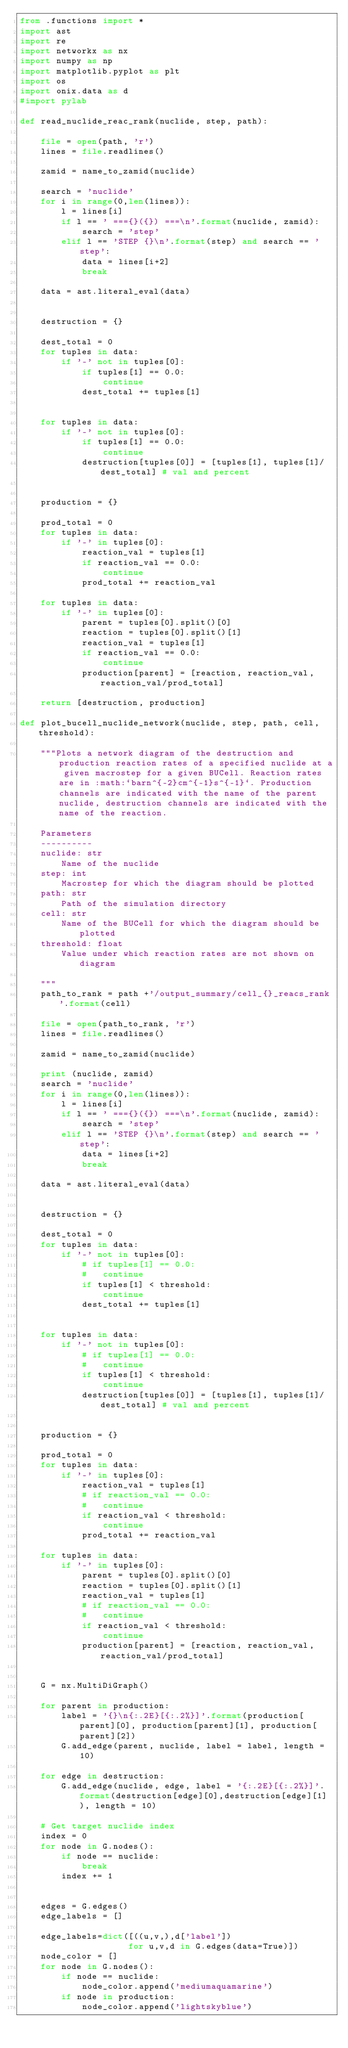Convert code to text. <code><loc_0><loc_0><loc_500><loc_500><_Python_>from .functions import *
import ast
import re
import networkx as nx
import numpy as np
import matplotlib.pyplot as plt
import os
import onix.data as d
#import pylab

def read_nuclide_reac_rank(nuclide, step, path):

    file = open(path, 'r')
    lines = file.readlines()

    zamid = name_to_zamid(nuclide)

    search = 'nuclide'
    for i in range(0,len(lines)):
        l = lines[i]
        if l == ' ==={}({}) ===\n'.format(nuclide, zamid):
            search = 'step'
        elif l == 'STEP {}\n'.format(step) and search == 'step':
            data = lines[i+2]
            break

    data = ast.literal_eval(data)


    destruction = {}

    dest_total = 0
    for tuples in data:
        if '-' not in tuples[0]:
            if tuples[1] == 0.0:
                continue
            dest_total += tuples[1]


    for tuples in data:
        if '-' not in tuples[0]:
            if tuples[1] == 0.0:
                continue
            destruction[tuples[0]] = [tuples[1], tuples[1]/dest_total] # val and percent


    production = {}

    prod_total = 0
    for tuples in data:
        if '-' in tuples[0]:
            reaction_val = tuples[1]
            if reaction_val == 0.0:
                continue    
            prod_total += reaction_val

    for tuples in data:
        if '-' in tuples[0]:
            parent = tuples[0].split()[0]
            reaction = tuples[0].split()[1]
            reaction_val = tuples[1]
            if reaction_val == 0.0:
                continue    
            production[parent] = [reaction, reaction_val, reaction_val/prod_total]

    return [destruction, production]

def plot_bucell_nuclide_network(nuclide, step, path, cell, threshold):
    
    """Plots a network diagram of the destruction and production reaction rates of a specified nuclide at a given macrostep for a given BUCell. Reaction rates are in :math:`barn^{-2}cm^{-1}s^{-1}`. Production channels are indicated with the name of the parent nuclide, destruction channels are indicated with the name of the reaction.

    Parameters
    ----------
    nuclide: str
        Name of the nuclide
    step: int
        Macrostep for which the diagram should be plotted
    path: str
        Path of the simulation directory
    cell: str
        Name of the BUCell for which the diagram should be plotted
    threshold: float
        Value under which reaction rates are not shown on diagram

    """
    path_to_rank = path +'/output_summary/cell_{}_reacs_rank'.format(cell)

    file = open(path_to_rank, 'r')
    lines = file.readlines()

    zamid = name_to_zamid(nuclide)

    print (nuclide, zamid)
    search = 'nuclide'
    for i in range(0,len(lines)):
        l = lines[i]
        if l == ' ==={}({}) ===\n'.format(nuclide, zamid):
            search = 'step'
        elif l == 'STEP {}\n'.format(step) and search == 'step':
            data = lines[i+2]
            break

    data = ast.literal_eval(data)


    destruction = {}

    dest_total = 0
    for tuples in data:
        if '-' not in tuples[0]:
            # if tuples[1] == 0.0:
            #   continue
            if tuples[1] < threshold:
                continue
            dest_total += tuples[1]


    for tuples in data:
        if '-' not in tuples[0]:
            # if tuples[1] == 0.0:
            #   continue
            if tuples[1] < threshold:
                continue
            destruction[tuples[0]] = [tuples[1], tuples[1]/dest_total] # val and percent


    production = {}

    prod_total = 0
    for tuples in data:
        if '-' in tuples[0]:
            reaction_val = tuples[1]
            # if reaction_val == 0.0:
            #   continue    
            if reaction_val < threshold:
                continue    
            prod_total += reaction_val

    for tuples in data:
        if '-' in tuples[0]:
            parent = tuples[0].split()[0]
            reaction = tuples[0].split()[1]
            reaction_val = tuples[1]
            # if reaction_val == 0.0:
            #   continue    
            if reaction_val < threshold:
                continue
            production[parent] = [reaction, reaction_val, reaction_val/prod_total]


    G = nx.MultiDiGraph()

    for parent in production:
        label = '{}\n{:.2E}[{:.2%}]'.format(production[parent][0], production[parent][1], production[parent][2])
        G.add_edge(parent, nuclide, label = label, length = 10)

    for edge in destruction:
        G.add_edge(nuclide, edge, label = '{:.2E}[{:.2%}]'.format(destruction[edge][0],destruction[edge][1] ), length = 10)

    # Get target nuclide index
    index = 0
    for node in G.nodes():
        if node == nuclide:
            break
        index += 1


    edges = G.edges()
    edge_labels = []

    edge_labels=dict([((u,v,),d['label'])
                     for u,v,d in G.edges(data=True)])
    node_color = []
    for node in G.nodes():
        if node == nuclide:
            node_color.append('mediumaquamarine')
        if node in production:
            node_color.append('lightskyblue')</code> 